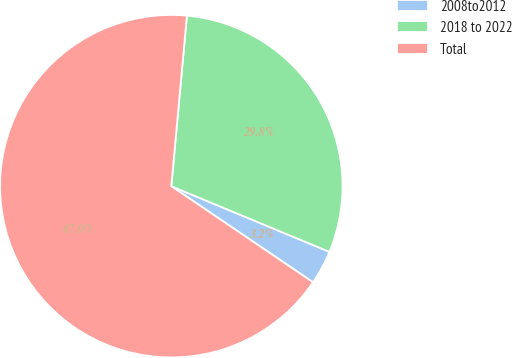Convert chart to OTSL. <chart><loc_0><loc_0><loc_500><loc_500><pie_chart><fcel>2008to2012<fcel>2018 to 2022<fcel>Total<nl><fcel>3.22%<fcel>29.81%<fcel>66.97%<nl></chart> 